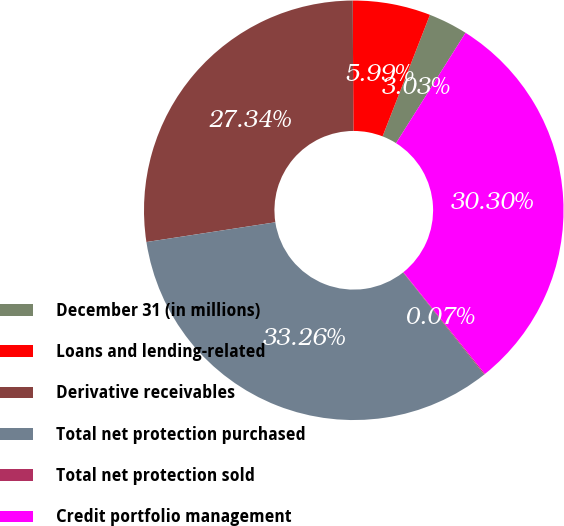Convert chart. <chart><loc_0><loc_0><loc_500><loc_500><pie_chart><fcel>December 31 (in millions)<fcel>Loans and lending-related<fcel>Derivative receivables<fcel>Total net protection purchased<fcel>Total net protection sold<fcel>Credit portfolio management<nl><fcel>3.03%<fcel>5.99%<fcel>27.34%<fcel>33.26%<fcel>0.07%<fcel>30.3%<nl></chart> 